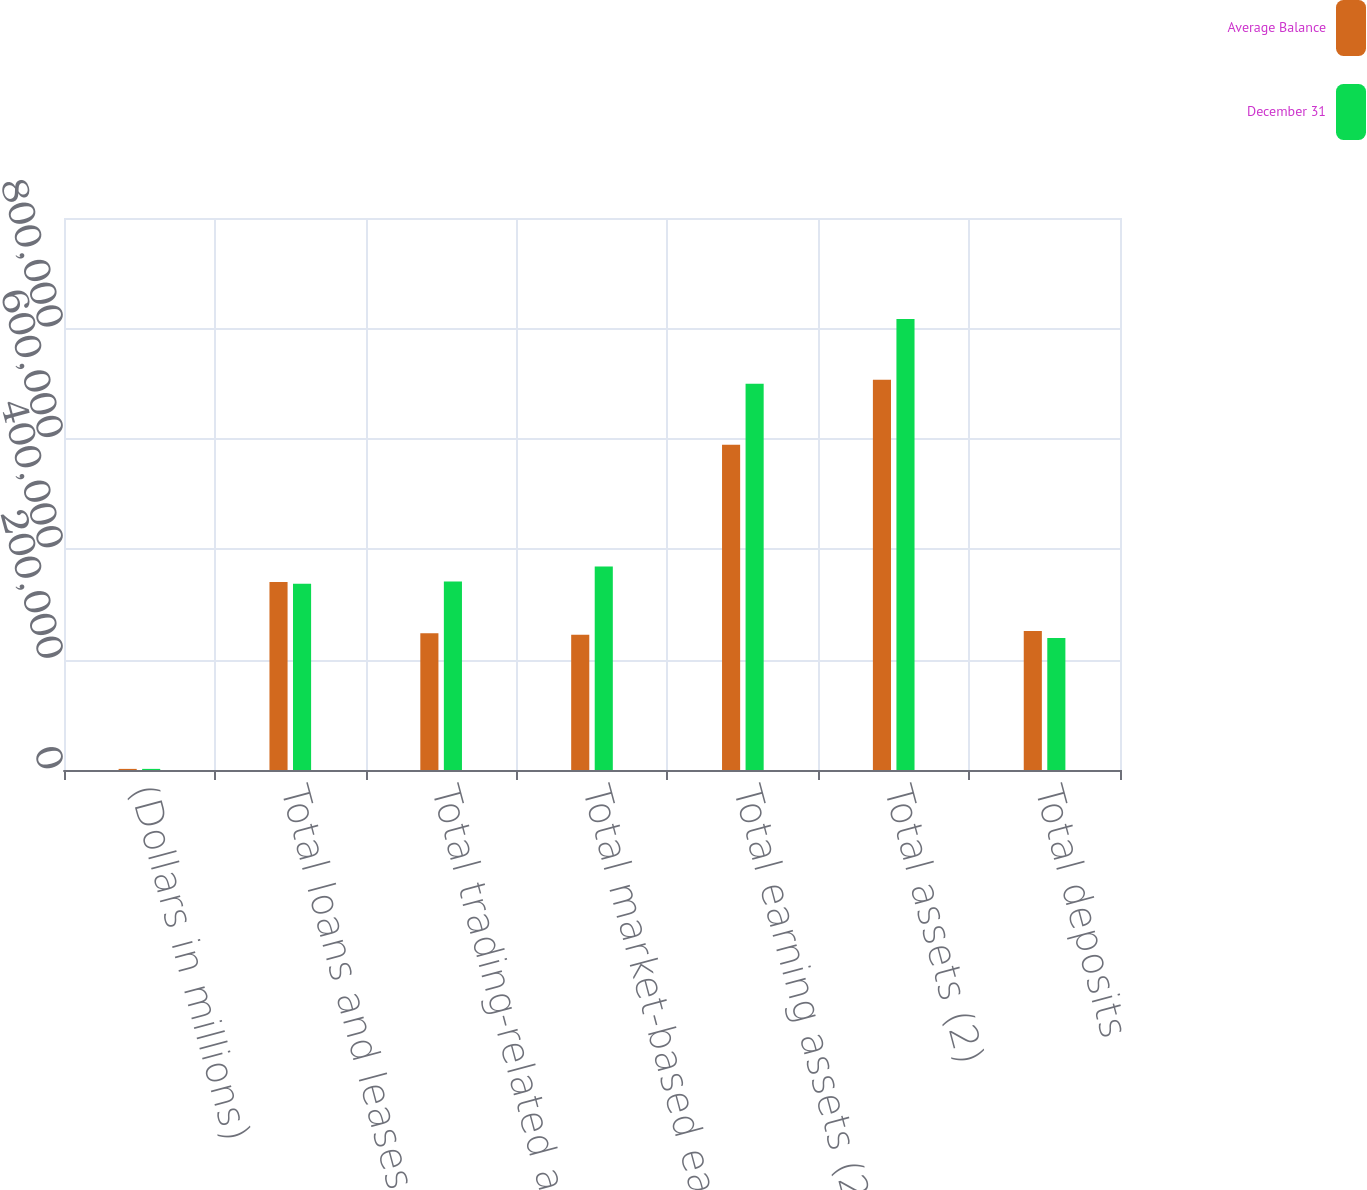Convert chart to OTSL. <chart><loc_0><loc_0><loc_500><loc_500><stacked_bar_chart><ecel><fcel>(Dollars in millions)<fcel>Total loans and leases<fcel>Total trading-related assets<fcel>Total market-based earning<fcel>Total earning assets (2)<fcel>Total assets (2)<fcel>Total deposits<nl><fcel>Average Balance<fcel>2008<fcel>340692<fcel>247552<fcel>244914<fcel>589431<fcel>707170<fcel>251798<nl><fcel>December 31<fcel>2008<fcel>337352<fcel>341544<fcel>368751<fcel>699708<fcel>816832<fcel>239097<nl></chart> 